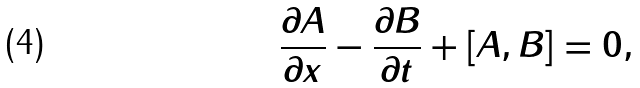<formula> <loc_0><loc_0><loc_500><loc_500>\frac { \partial A } { \partial x } - \frac { \partial B } { \partial t } + [ A , B ] = 0 ,</formula> 